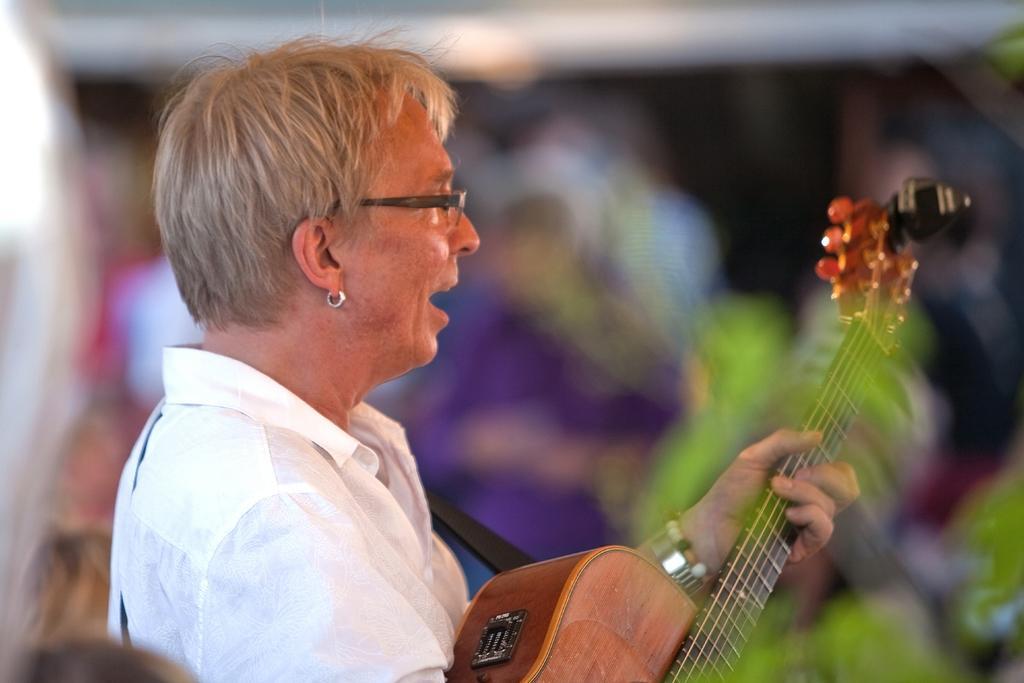How would you summarize this image in a sentence or two? In this image we can see an old woman is holding a guitar in her hands. 